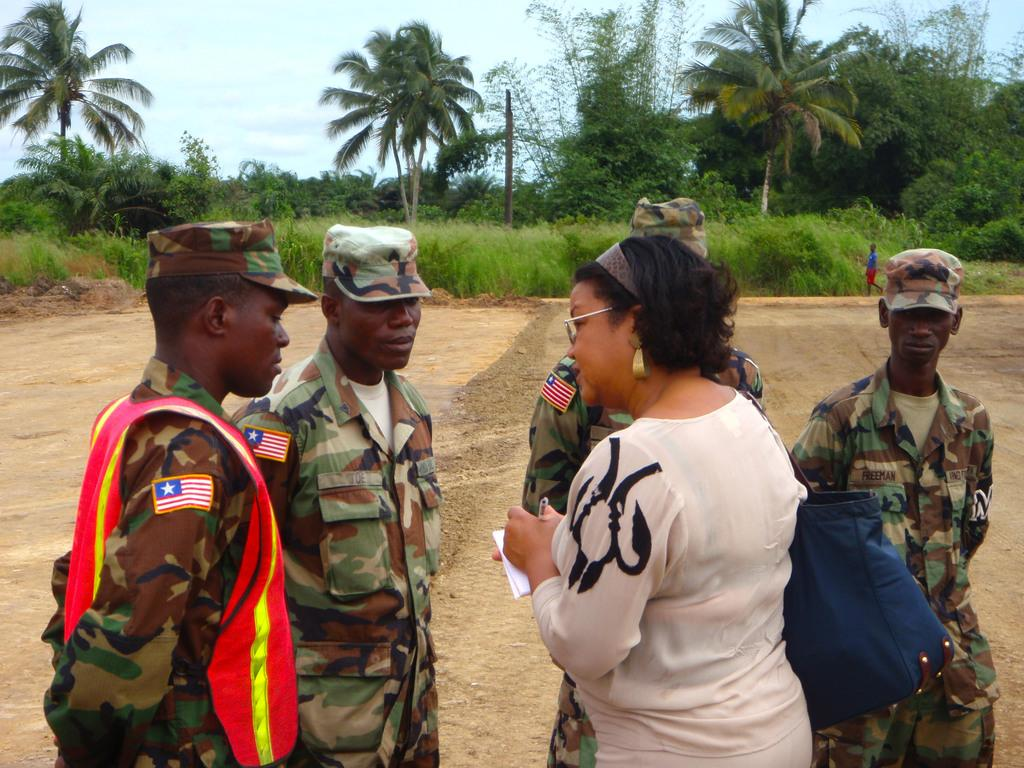How many people are present in the image? There are people in the image, but the exact number is not specified. What is the person wearing a bag holding? The person with the bag is holding a book and a pen. What can be seen in the background of the image? Trees, plants, at least one person, a pole, and the sky are visible in the background of the image. How many eyes can be seen on the table in the image? There is no table or eyes present in the image. 